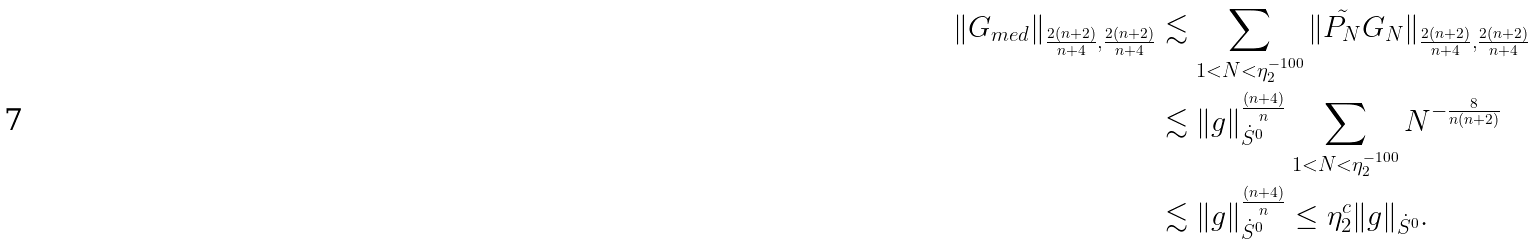<formula> <loc_0><loc_0><loc_500><loc_500>\| G _ { m e d } \| _ { \frac { 2 ( n + 2 ) } { n + 4 } , \frac { 2 ( n + 2 ) } { n + 4 } } & \lesssim \sum _ { 1 < N < \eta _ { 2 } ^ { - 1 0 0 } } \| \tilde { P _ { N } } G _ { N } \| _ { \frac { 2 ( n + 2 ) } { n + 4 } , \frac { 2 ( n + 2 ) } { n + 4 } } \\ & \lesssim \| g \| _ { \dot { S } ^ { 0 } } ^ { \frac { ( n + 4 ) } { n } } \sum _ { 1 < N < \eta _ { 2 } ^ { - 1 0 0 } } N ^ { - \frac { 8 } { n ( n + 2 ) } } \\ & \lesssim \| g \| _ { \dot { S } ^ { 0 } } ^ { \frac { ( n + 4 ) } { n } } \leq \eta _ { 2 } ^ { c } \| g \| _ { \dot { S } ^ { 0 } } .</formula> 